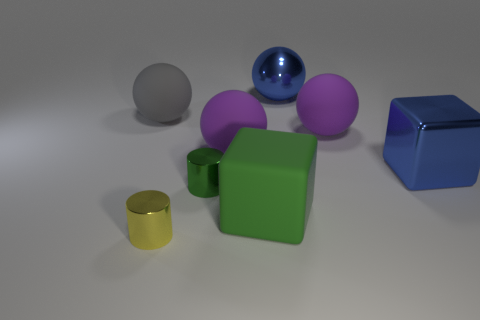There is a metal object that is to the right of the tiny green cylinder and on the left side of the metal block; how big is it?
Provide a short and direct response. Large. There is a large matte block; is its color the same as the tiny metallic cylinder behind the yellow metallic cylinder?
Make the answer very short. Yes. Is there a big blue matte object of the same shape as the large green matte object?
Keep it short and to the point. No. What number of objects are shiny cylinders or big matte things that are to the left of the green cube?
Your answer should be compact. 4. What number of things are either green metallic things or big blue shiny blocks?
Make the answer very short. 2. Are there more metallic things that are behind the large green matte object than big blue cubes that are behind the large gray sphere?
Offer a terse response. Yes. Do the tiny cylinder that is in front of the small green metal cylinder and the large metallic object that is on the right side of the big blue sphere have the same color?
Give a very brief answer. No. What size is the cube to the left of the blue thing that is in front of the gray thing that is behind the big blue metal block?
Your response must be concise. Large. There is another large metallic thing that is the same shape as the large green object; what is its color?
Provide a succinct answer. Blue. Is the number of green rubber blocks that are behind the big green rubber block greater than the number of shiny spheres?
Offer a terse response. No. 